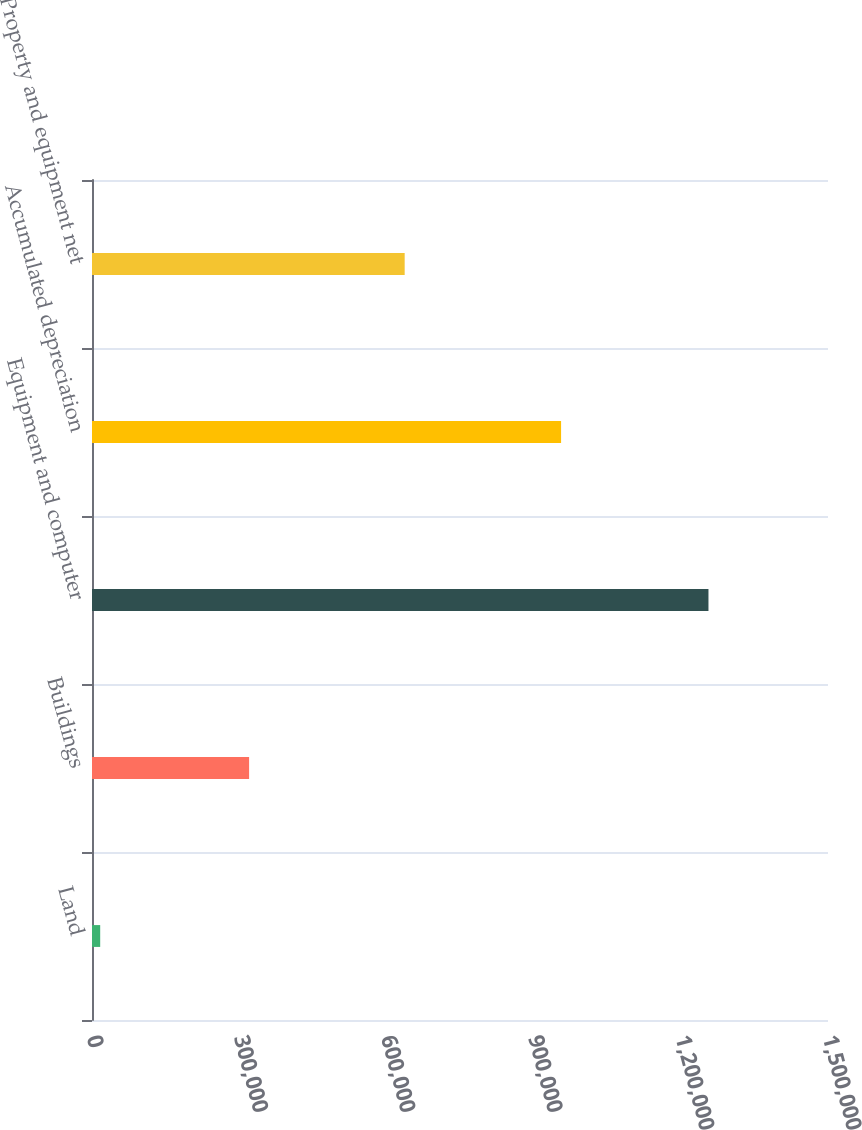Convert chart. <chart><loc_0><loc_0><loc_500><loc_500><bar_chart><fcel>Land<fcel>Buildings<fcel>Equipment and computer<fcel>Accumulated depreciation<fcel>Property and equipment net<nl><fcel>16699<fcel>320180<fcel>1.25638e+06<fcel>956020<fcel>637241<nl></chart> 